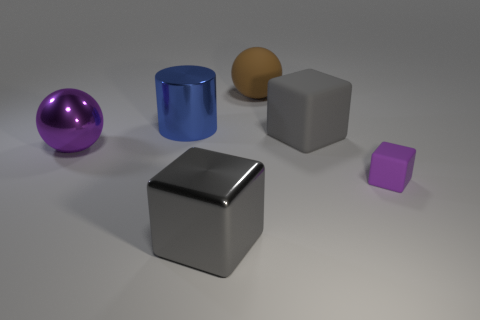There is a gray thing behind the small purple thing; is it the same shape as the small purple matte object?
Ensure brevity in your answer.  Yes. What number of blue objects are large cylinders or metallic cubes?
Keep it short and to the point. 1. Is the number of large gray things greater than the number of big blue balls?
Offer a very short reply. Yes. There is a cylinder that is the same size as the brown object; what is its color?
Make the answer very short. Blue. How many spheres are purple objects or tiny green rubber things?
Offer a terse response. 1. There is a big purple metal thing; is its shape the same as the matte thing that is left of the gray matte object?
Keep it short and to the point. Yes. How many other matte objects have the same size as the purple matte thing?
Your answer should be very brief. 0. There is a big gray thing in front of the purple metal sphere; is it the same shape as the gray object behind the small matte thing?
Your answer should be compact. Yes. What shape is the big metal object that is the same color as the small rubber object?
Offer a terse response. Sphere. The large thing that is in front of the large ball in front of the brown matte ball is what color?
Offer a terse response. Gray. 